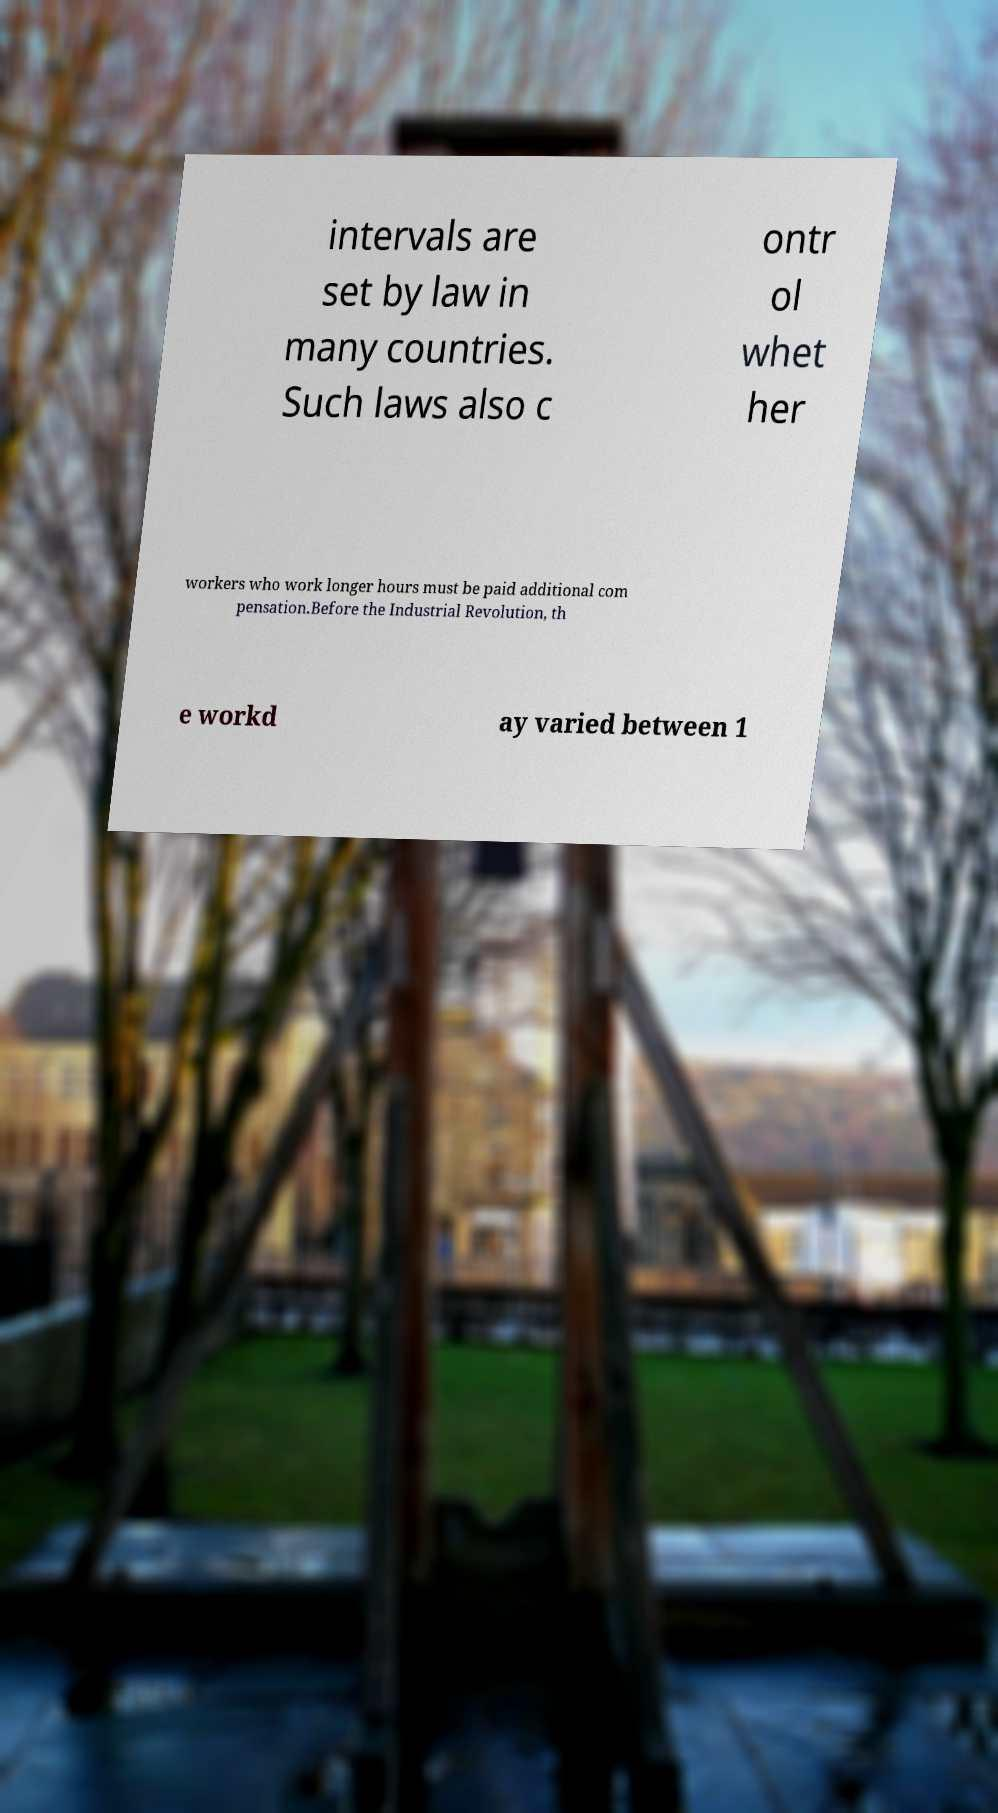Please identify and transcribe the text found in this image. intervals are set by law in many countries. Such laws also c ontr ol whet her workers who work longer hours must be paid additional com pensation.Before the Industrial Revolution, th e workd ay varied between 1 